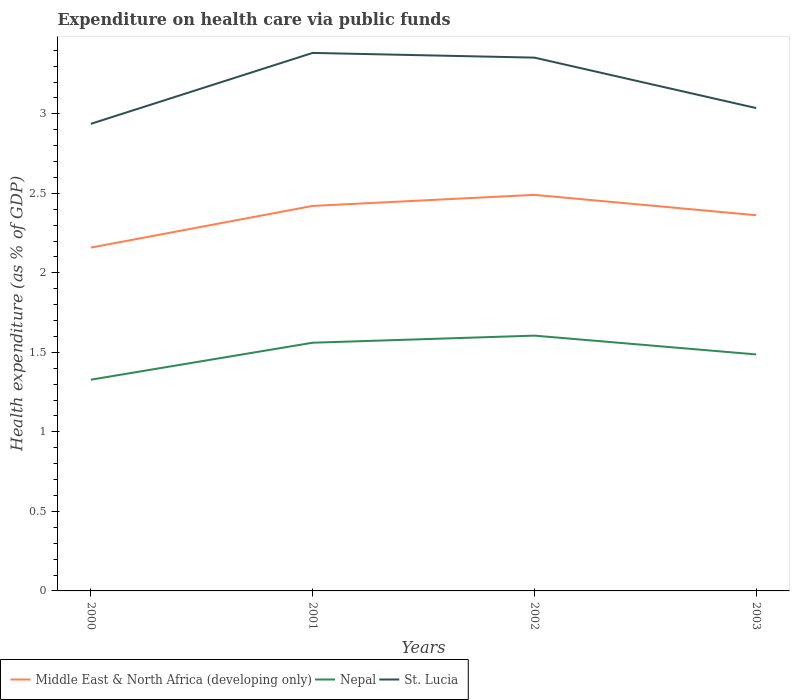Does the line corresponding to Nepal intersect with the line corresponding to Middle East & North Africa (developing only)?
Keep it short and to the point. No. Across all years, what is the maximum expenditure made on health care in Nepal?
Offer a very short reply. 1.33. What is the total expenditure made on health care in Nepal in the graph?
Your response must be concise. -0.23. What is the difference between the highest and the second highest expenditure made on health care in St. Lucia?
Keep it short and to the point. 0.45. How many lines are there?
Ensure brevity in your answer.  3. What is the difference between two consecutive major ticks on the Y-axis?
Provide a short and direct response. 0.5. Does the graph contain grids?
Keep it short and to the point. No. Where does the legend appear in the graph?
Provide a short and direct response. Bottom left. How many legend labels are there?
Provide a short and direct response. 3. How are the legend labels stacked?
Provide a succinct answer. Horizontal. What is the title of the graph?
Provide a short and direct response. Expenditure on health care via public funds. What is the label or title of the Y-axis?
Keep it short and to the point. Health expenditure (as % of GDP). What is the Health expenditure (as % of GDP) of Middle East & North Africa (developing only) in 2000?
Your response must be concise. 2.16. What is the Health expenditure (as % of GDP) of Nepal in 2000?
Provide a succinct answer. 1.33. What is the Health expenditure (as % of GDP) in St. Lucia in 2000?
Keep it short and to the point. 2.94. What is the Health expenditure (as % of GDP) of Middle East & North Africa (developing only) in 2001?
Keep it short and to the point. 2.42. What is the Health expenditure (as % of GDP) in Nepal in 2001?
Offer a terse response. 1.56. What is the Health expenditure (as % of GDP) of St. Lucia in 2001?
Give a very brief answer. 3.38. What is the Health expenditure (as % of GDP) of Middle East & North Africa (developing only) in 2002?
Your response must be concise. 2.49. What is the Health expenditure (as % of GDP) in Nepal in 2002?
Make the answer very short. 1.61. What is the Health expenditure (as % of GDP) in St. Lucia in 2002?
Your answer should be very brief. 3.35. What is the Health expenditure (as % of GDP) of Middle East & North Africa (developing only) in 2003?
Your answer should be compact. 2.36. What is the Health expenditure (as % of GDP) of Nepal in 2003?
Ensure brevity in your answer.  1.49. What is the Health expenditure (as % of GDP) in St. Lucia in 2003?
Ensure brevity in your answer.  3.04. Across all years, what is the maximum Health expenditure (as % of GDP) in Middle East & North Africa (developing only)?
Offer a very short reply. 2.49. Across all years, what is the maximum Health expenditure (as % of GDP) of Nepal?
Keep it short and to the point. 1.61. Across all years, what is the maximum Health expenditure (as % of GDP) in St. Lucia?
Make the answer very short. 3.38. Across all years, what is the minimum Health expenditure (as % of GDP) of Middle East & North Africa (developing only)?
Provide a succinct answer. 2.16. Across all years, what is the minimum Health expenditure (as % of GDP) in Nepal?
Offer a terse response. 1.33. Across all years, what is the minimum Health expenditure (as % of GDP) of St. Lucia?
Your response must be concise. 2.94. What is the total Health expenditure (as % of GDP) of Middle East & North Africa (developing only) in the graph?
Offer a very short reply. 9.43. What is the total Health expenditure (as % of GDP) in Nepal in the graph?
Offer a very short reply. 5.98. What is the total Health expenditure (as % of GDP) of St. Lucia in the graph?
Provide a short and direct response. 12.71. What is the difference between the Health expenditure (as % of GDP) of Middle East & North Africa (developing only) in 2000 and that in 2001?
Your response must be concise. -0.26. What is the difference between the Health expenditure (as % of GDP) in Nepal in 2000 and that in 2001?
Ensure brevity in your answer.  -0.23. What is the difference between the Health expenditure (as % of GDP) in St. Lucia in 2000 and that in 2001?
Keep it short and to the point. -0.45. What is the difference between the Health expenditure (as % of GDP) in Middle East & North Africa (developing only) in 2000 and that in 2002?
Provide a short and direct response. -0.33. What is the difference between the Health expenditure (as % of GDP) of Nepal in 2000 and that in 2002?
Give a very brief answer. -0.28. What is the difference between the Health expenditure (as % of GDP) in St. Lucia in 2000 and that in 2002?
Provide a short and direct response. -0.42. What is the difference between the Health expenditure (as % of GDP) in Middle East & North Africa (developing only) in 2000 and that in 2003?
Give a very brief answer. -0.2. What is the difference between the Health expenditure (as % of GDP) of Nepal in 2000 and that in 2003?
Keep it short and to the point. -0.16. What is the difference between the Health expenditure (as % of GDP) in St. Lucia in 2000 and that in 2003?
Your response must be concise. -0.1. What is the difference between the Health expenditure (as % of GDP) in Middle East & North Africa (developing only) in 2001 and that in 2002?
Keep it short and to the point. -0.07. What is the difference between the Health expenditure (as % of GDP) of Nepal in 2001 and that in 2002?
Offer a terse response. -0.04. What is the difference between the Health expenditure (as % of GDP) in St. Lucia in 2001 and that in 2002?
Make the answer very short. 0.03. What is the difference between the Health expenditure (as % of GDP) in Middle East & North Africa (developing only) in 2001 and that in 2003?
Provide a short and direct response. 0.06. What is the difference between the Health expenditure (as % of GDP) of Nepal in 2001 and that in 2003?
Your answer should be compact. 0.07. What is the difference between the Health expenditure (as % of GDP) in St. Lucia in 2001 and that in 2003?
Your answer should be very brief. 0.35. What is the difference between the Health expenditure (as % of GDP) of Middle East & North Africa (developing only) in 2002 and that in 2003?
Ensure brevity in your answer.  0.13. What is the difference between the Health expenditure (as % of GDP) in Nepal in 2002 and that in 2003?
Give a very brief answer. 0.12. What is the difference between the Health expenditure (as % of GDP) of St. Lucia in 2002 and that in 2003?
Your response must be concise. 0.32. What is the difference between the Health expenditure (as % of GDP) of Middle East & North Africa (developing only) in 2000 and the Health expenditure (as % of GDP) of Nepal in 2001?
Ensure brevity in your answer.  0.6. What is the difference between the Health expenditure (as % of GDP) of Middle East & North Africa (developing only) in 2000 and the Health expenditure (as % of GDP) of St. Lucia in 2001?
Give a very brief answer. -1.22. What is the difference between the Health expenditure (as % of GDP) in Nepal in 2000 and the Health expenditure (as % of GDP) in St. Lucia in 2001?
Your answer should be very brief. -2.05. What is the difference between the Health expenditure (as % of GDP) of Middle East & North Africa (developing only) in 2000 and the Health expenditure (as % of GDP) of Nepal in 2002?
Offer a terse response. 0.55. What is the difference between the Health expenditure (as % of GDP) in Middle East & North Africa (developing only) in 2000 and the Health expenditure (as % of GDP) in St. Lucia in 2002?
Provide a short and direct response. -1.19. What is the difference between the Health expenditure (as % of GDP) of Nepal in 2000 and the Health expenditure (as % of GDP) of St. Lucia in 2002?
Provide a succinct answer. -2.03. What is the difference between the Health expenditure (as % of GDP) of Middle East & North Africa (developing only) in 2000 and the Health expenditure (as % of GDP) of Nepal in 2003?
Offer a very short reply. 0.67. What is the difference between the Health expenditure (as % of GDP) in Middle East & North Africa (developing only) in 2000 and the Health expenditure (as % of GDP) in St. Lucia in 2003?
Offer a very short reply. -0.88. What is the difference between the Health expenditure (as % of GDP) of Nepal in 2000 and the Health expenditure (as % of GDP) of St. Lucia in 2003?
Give a very brief answer. -1.71. What is the difference between the Health expenditure (as % of GDP) in Middle East & North Africa (developing only) in 2001 and the Health expenditure (as % of GDP) in Nepal in 2002?
Your answer should be very brief. 0.82. What is the difference between the Health expenditure (as % of GDP) in Middle East & North Africa (developing only) in 2001 and the Health expenditure (as % of GDP) in St. Lucia in 2002?
Your response must be concise. -0.93. What is the difference between the Health expenditure (as % of GDP) in Nepal in 2001 and the Health expenditure (as % of GDP) in St. Lucia in 2002?
Your answer should be compact. -1.79. What is the difference between the Health expenditure (as % of GDP) of Middle East & North Africa (developing only) in 2001 and the Health expenditure (as % of GDP) of Nepal in 2003?
Provide a short and direct response. 0.93. What is the difference between the Health expenditure (as % of GDP) in Middle East & North Africa (developing only) in 2001 and the Health expenditure (as % of GDP) in St. Lucia in 2003?
Ensure brevity in your answer.  -0.62. What is the difference between the Health expenditure (as % of GDP) of Nepal in 2001 and the Health expenditure (as % of GDP) of St. Lucia in 2003?
Give a very brief answer. -1.48. What is the difference between the Health expenditure (as % of GDP) in Middle East & North Africa (developing only) in 2002 and the Health expenditure (as % of GDP) in Nepal in 2003?
Provide a short and direct response. 1. What is the difference between the Health expenditure (as % of GDP) of Middle East & North Africa (developing only) in 2002 and the Health expenditure (as % of GDP) of St. Lucia in 2003?
Your answer should be very brief. -0.55. What is the difference between the Health expenditure (as % of GDP) of Nepal in 2002 and the Health expenditure (as % of GDP) of St. Lucia in 2003?
Offer a terse response. -1.43. What is the average Health expenditure (as % of GDP) in Middle East & North Africa (developing only) per year?
Offer a very short reply. 2.36. What is the average Health expenditure (as % of GDP) of Nepal per year?
Provide a succinct answer. 1.5. What is the average Health expenditure (as % of GDP) of St. Lucia per year?
Your answer should be very brief. 3.18. In the year 2000, what is the difference between the Health expenditure (as % of GDP) of Middle East & North Africa (developing only) and Health expenditure (as % of GDP) of Nepal?
Keep it short and to the point. 0.83. In the year 2000, what is the difference between the Health expenditure (as % of GDP) of Middle East & North Africa (developing only) and Health expenditure (as % of GDP) of St. Lucia?
Provide a short and direct response. -0.78. In the year 2000, what is the difference between the Health expenditure (as % of GDP) of Nepal and Health expenditure (as % of GDP) of St. Lucia?
Give a very brief answer. -1.61. In the year 2001, what is the difference between the Health expenditure (as % of GDP) of Middle East & North Africa (developing only) and Health expenditure (as % of GDP) of Nepal?
Your response must be concise. 0.86. In the year 2001, what is the difference between the Health expenditure (as % of GDP) of Middle East & North Africa (developing only) and Health expenditure (as % of GDP) of St. Lucia?
Your answer should be very brief. -0.96. In the year 2001, what is the difference between the Health expenditure (as % of GDP) in Nepal and Health expenditure (as % of GDP) in St. Lucia?
Keep it short and to the point. -1.82. In the year 2002, what is the difference between the Health expenditure (as % of GDP) of Middle East & North Africa (developing only) and Health expenditure (as % of GDP) of Nepal?
Keep it short and to the point. 0.89. In the year 2002, what is the difference between the Health expenditure (as % of GDP) in Middle East & North Africa (developing only) and Health expenditure (as % of GDP) in St. Lucia?
Give a very brief answer. -0.86. In the year 2002, what is the difference between the Health expenditure (as % of GDP) of Nepal and Health expenditure (as % of GDP) of St. Lucia?
Keep it short and to the point. -1.75. In the year 2003, what is the difference between the Health expenditure (as % of GDP) of Middle East & North Africa (developing only) and Health expenditure (as % of GDP) of Nepal?
Offer a very short reply. 0.88. In the year 2003, what is the difference between the Health expenditure (as % of GDP) of Middle East & North Africa (developing only) and Health expenditure (as % of GDP) of St. Lucia?
Provide a short and direct response. -0.67. In the year 2003, what is the difference between the Health expenditure (as % of GDP) of Nepal and Health expenditure (as % of GDP) of St. Lucia?
Provide a short and direct response. -1.55. What is the ratio of the Health expenditure (as % of GDP) in Middle East & North Africa (developing only) in 2000 to that in 2001?
Your response must be concise. 0.89. What is the ratio of the Health expenditure (as % of GDP) in Nepal in 2000 to that in 2001?
Give a very brief answer. 0.85. What is the ratio of the Health expenditure (as % of GDP) of St. Lucia in 2000 to that in 2001?
Your answer should be very brief. 0.87. What is the ratio of the Health expenditure (as % of GDP) in Middle East & North Africa (developing only) in 2000 to that in 2002?
Give a very brief answer. 0.87. What is the ratio of the Health expenditure (as % of GDP) in Nepal in 2000 to that in 2002?
Your answer should be compact. 0.83. What is the ratio of the Health expenditure (as % of GDP) of St. Lucia in 2000 to that in 2002?
Keep it short and to the point. 0.88. What is the ratio of the Health expenditure (as % of GDP) in Middle East & North Africa (developing only) in 2000 to that in 2003?
Provide a succinct answer. 0.91. What is the ratio of the Health expenditure (as % of GDP) of Nepal in 2000 to that in 2003?
Your answer should be compact. 0.89. What is the ratio of the Health expenditure (as % of GDP) of St. Lucia in 2000 to that in 2003?
Offer a very short reply. 0.97. What is the ratio of the Health expenditure (as % of GDP) of Middle East & North Africa (developing only) in 2001 to that in 2002?
Your answer should be compact. 0.97. What is the ratio of the Health expenditure (as % of GDP) in Nepal in 2001 to that in 2002?
Make the answer very short. 0.97. What is the ratio of the Health expenditure (as % of GDP) of St. Lucia in 2001 to that in 2002?
Offer a terse response. 1.01. What is the ratio of the Health expenditure (as % of GDP) in Middle East & North Africa (developing only) in 2001 to that in 2003?
Make the answer very short. 1.02. What is the ratio of the Health expenditure (as % of GDP) in Nepal in 2001 to that in 2003?
Your answer should be compact. 1.05. What is the ratio of the Health expenditure (as % of GDP) of St. Lucia in 2001 to that in 2003?
Offer a terse response. 1.11. What is the ratio of the Health expenditure (as % of GDP) of Middle East & North Africa (developing only) in 2002 to that in 2003?
Offer a terse response. 1.05. What is the ratio of the Health expenditure (as % of GDP) in Nepal in 2002 to that in 2003?
Make the answer very short. 1.08. What is the ratio of the Health expenditure (as % of GDP) in St. Lucia in 2002 to that in 2003?
Your answer should be compact. 1.1. What is the difference between the highest and the second highest Health expenditure (as % of GDP) in Middle East & North Africa (developing only)?
Provide a short and direct response. 0.07. What is the difference between the highest and the second highest Health expenditure (as % of GDP) in Nepal?
Ensure brevity in your answer.  0.04. What is the difference between the highest and the second highest Health expenditure (as % of GDP) of St. Lucia?
Offer a terse response. 0.03. What is the difference between the highest and the lowest Health expenditure (as % of GDP) of Middle East & North Africa (developing only)?
Your answer should be compact. 0.33. What is the difference between the highest and the lowest Health expenditure (as % of GDP) of Nepal?
Your answer should be compact. 0.28. What is the difference between the highest and the lowest Health expenditure (as % of GDP) of St. Lucia?
Your response must be concise. 0.45. 